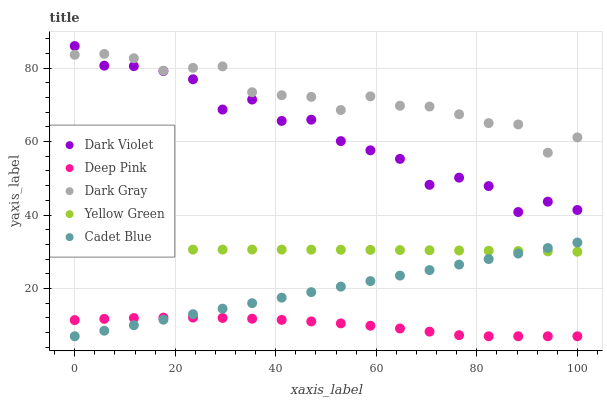Does Deep Pink have the minimum area under the curve?
Answer yes or no. Yes. Does Dark Gray have the maximum area under the curve?
Answer yes or no. Yes. Does Cadet Blue have the minimum area under the curve?
Answer yes or no. No. Does Cadet Blue have the maximum area under the curve?
Answer yes or no. No. Is Cadet Blue the smoothest?
Answer yes or no. Yes. Is Dark Violet the roughest?
Answer yes or no. Yes. Is Deep Pink the smoothest?
Answer yes or no. No. Is Deep Pink the roughest?
Answer yes or no. No. Does Deep Pink have the lowest value?
Answer yes or no. Yes. Does Yellow Green have the lowest value?
Answer yes or no. No. Does Dark Violet have the highest value?
Answer yes or no. Yes. Does Cadet Blue have the highest value?
Answer yes or no. No. Is Deep Pink less than Yellow Green?
Answer yes or no. Yes. Is Dark Gray greater than Yellow Green?
Answer yes or no. Yes. Does Yellow Green intersect Cadet Blue?
Answer yes or no. Yes. Is Yellow Green less than Cadet Blue?
Answer yes or no. No. Is Yellow Green greater than Cadet Blue?
Answer yes or no. No. Does Deep Pink intersect Yellow Green?
Answer yes or no. No. 